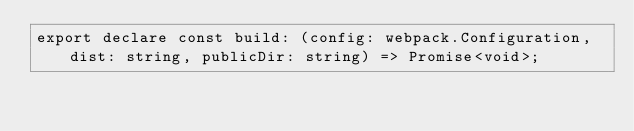<code> <loc_0><loc_0><loc_500><loc_500><_TypeScript_>export declare const build: (config: webpack.Configuration, dist: string, publicDir: string) => Promise<void>;
</code> 